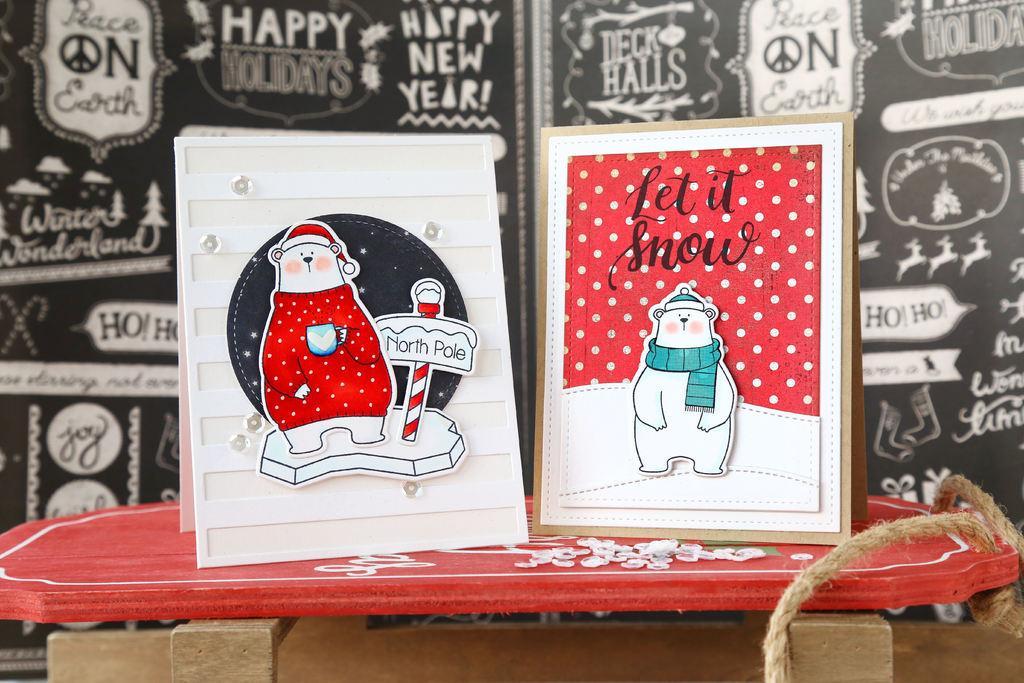Describe this image in one or two sentences. In the image in the center we can see one table. On the table,we can see frames,rope etc. On one of the frame,it is written as "Let It Snow". In the background there is a banner. 